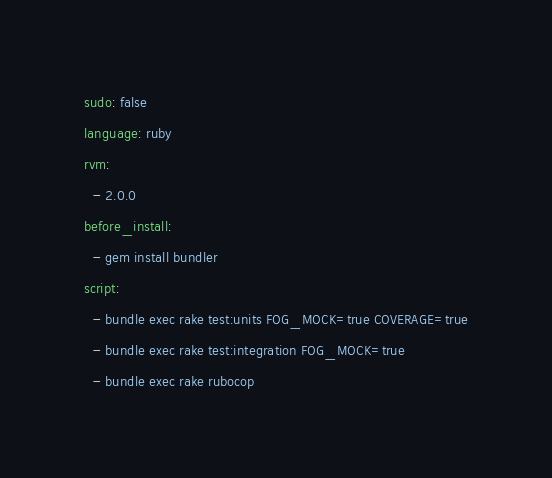Convert code to text. <code><loc_0><loc_0><loc_500><loc_500><_YAML_>sudo: false
language: ruby
rvm:
  - 2.0.0
before_install:
  - gem install bundler
script:
  - bundle exec rake test:units FOG_MOCK=true COVERAGE=true
  - bundle exec rake test:integration FOG_MOCK=true
  - bundle exec rake rubocop
</code> 